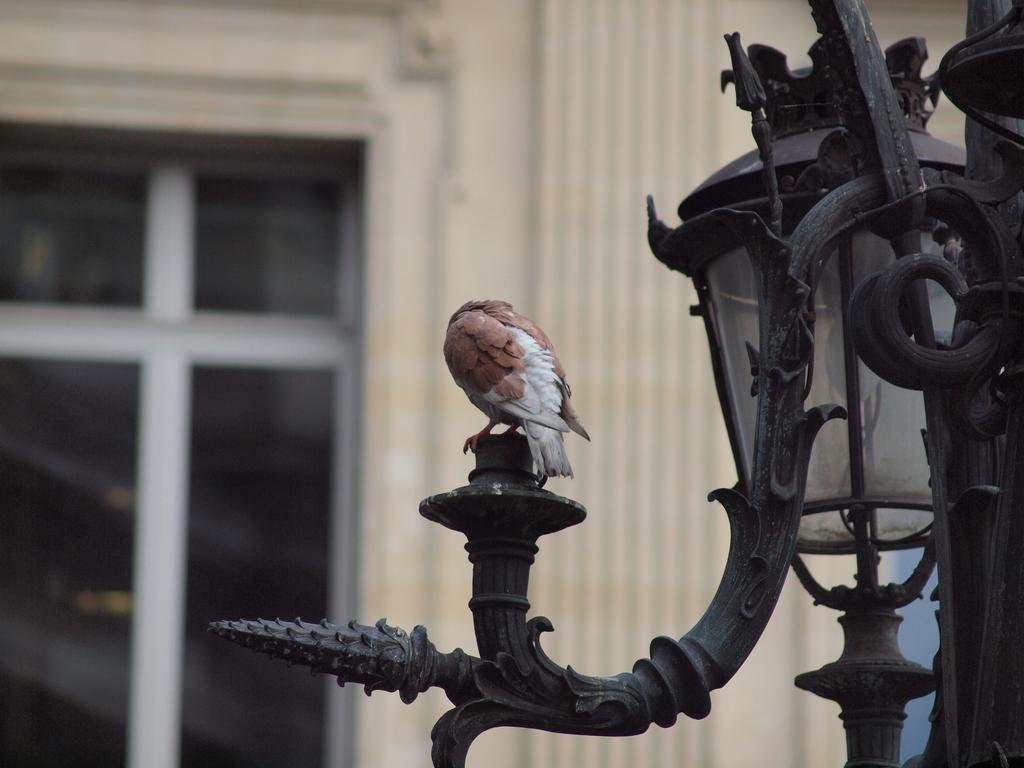What type of animal can be seen in the image? There is a bird in the image. Where is the bird located? The bird is standing on a street light pole handle. What can be seen in the background of the image? There is a building visible in the background of the image. What arithmetic problem is the bird solving in the image? There is no arithmetic problem present in the image; it features a bird standing on a street light pole handle. Can you hear the bird whistling in the image? There is no indication of sound in the image, so it cannot be determined if the bird is whistling. 